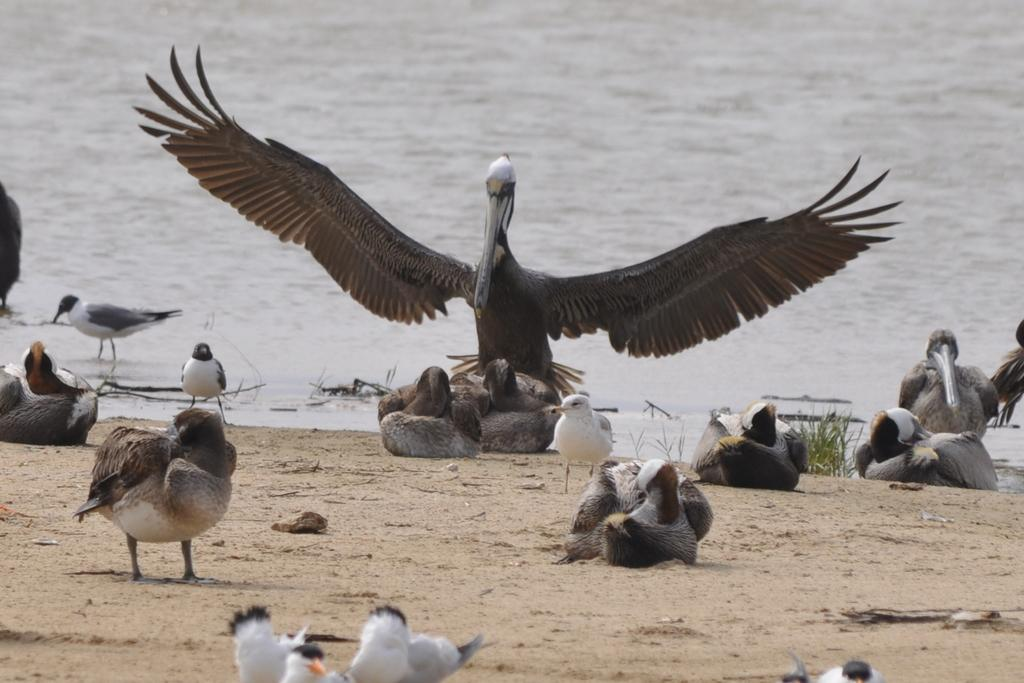What type of animals are on the ground in the image? There are birds on the ground in the image. What type of vegetation is visible in the image? There is grass visible in the image. What can be seen in the background of the image? There is water visible in the background of the image. What type of jam is being spread on the country in the image? There is no jam or country present in the image; it features birds on the ground and grass. 